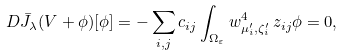<formula> <loc_0><loc_0><loc_500><loc_500>D \bar { J } _ { \lambda } ( V + \phi ) [ \phi ] & = - \sum _ { i , j } c _ { i j } \int _ { \Omega _ { \varepsilon } } w _ { \mu _ { i } ^ { \prime } , \zeta _ { i } ^ { \prime } } ^ { 4 } \, z _ { i j } \phi = 0 ,</formula> 